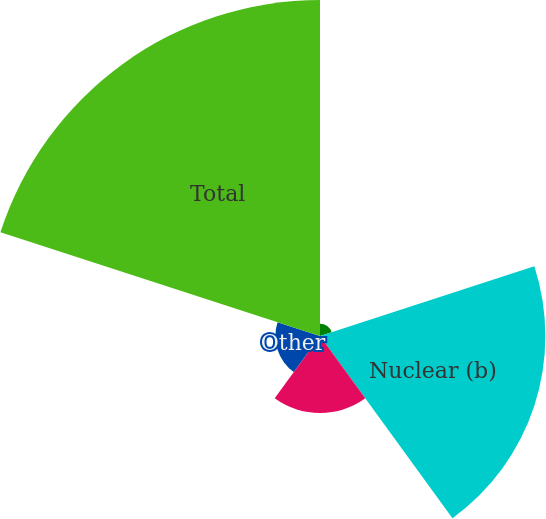Convert chart. <chart><loc_0><loc_0><loc_500><loc_500><pie_chart><fcel>Wind (a)<fcel>Nuclear (b)<fcel>Natural gas<fcel>Other<fcel>Total<nl><fcel>1.77%<fcel>32.41%<fcel>11.08%<fcel>6.42%<fcel>48.32%<nl></chart> 